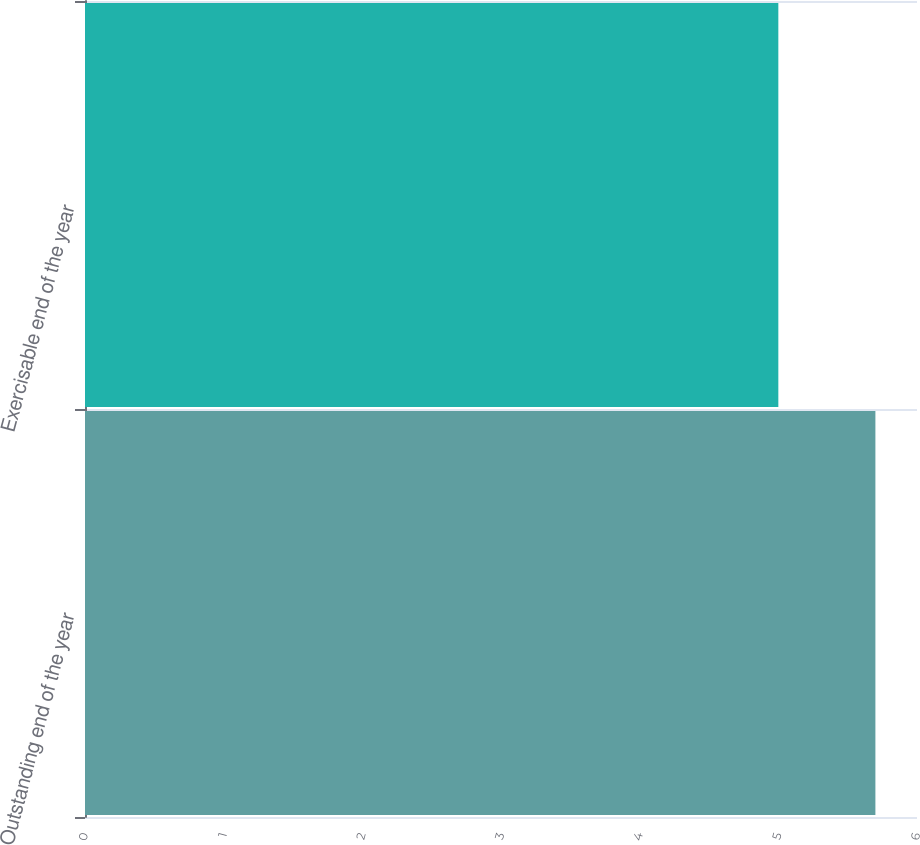<chart> <loc_0><loc_0><loc_500><loc_500><bar_chart><fcel>Outstanding end of the year<fcel>Exercisable end of the year<nl><fcel>5.7<fcel>5<nl></chart> 